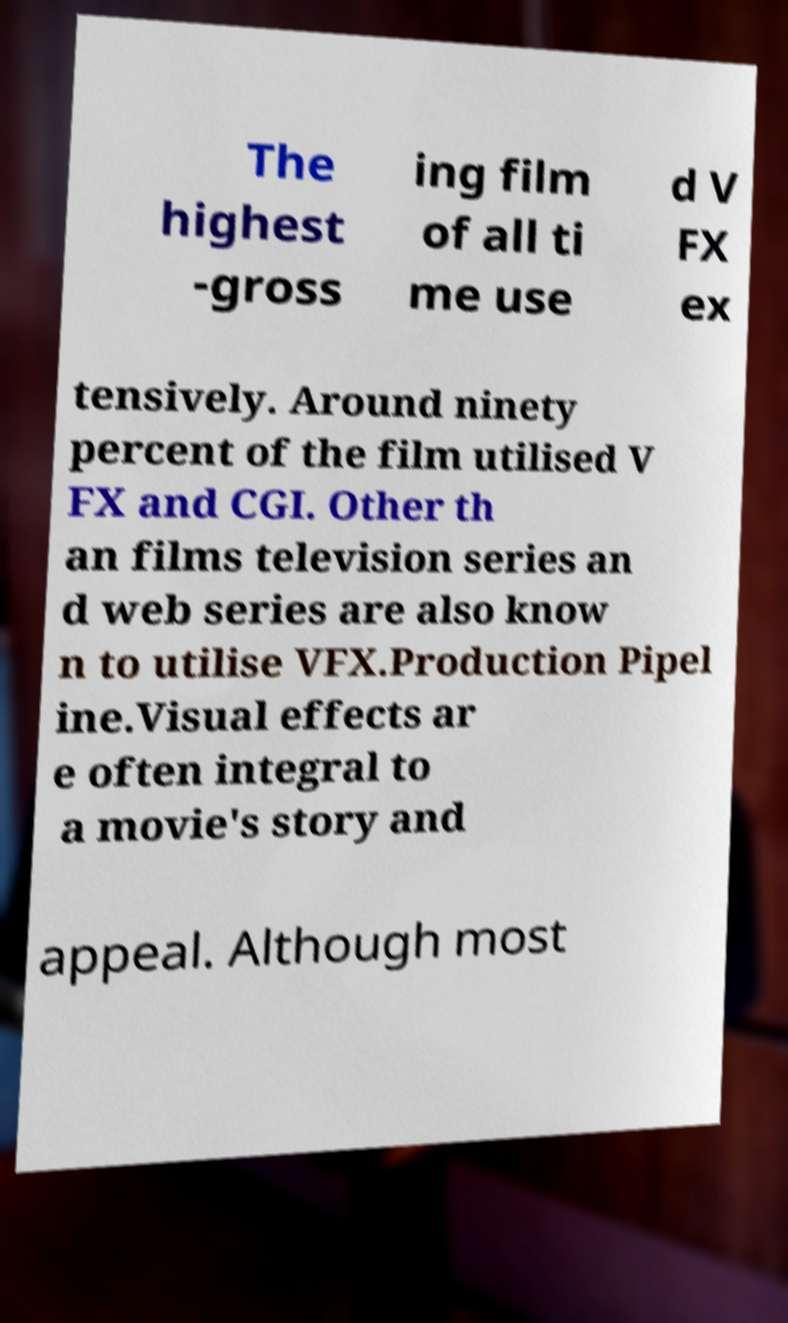What messages or text are displayed in this image? I need them in a readable, typed format. The highest -gross ing film of all ti me use d V FX ex tensively. Around ninety percent of the film utilised V FX and CGI. Other th an films television series an d web series are also know n to utilise VFX.Production Pipel ine.Visual effects ar e often integral to a movie's story and appeal. Although most 